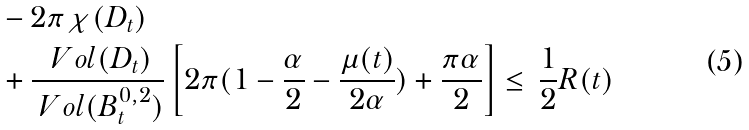Convert formula to latex. <formula><loc_0><loc_0><loc_500><loc_500>& - 2 \pi \chi ( D _ { t } ) \\ & + \frac { \ V o l ( D _ { t } ) } { \ V o l ( B _ { t } ^ { 0 , 2 } ) } \left [ 2 \pi ( 1 - \frac { \alpha } { 2 } - \frac { \mu ( t ) } { 2 \alpha } ) + \frac { \pi \alpha } { 2 } \right ] \leq \, \frac { 1 } { 2 } R ( t )</formula> 